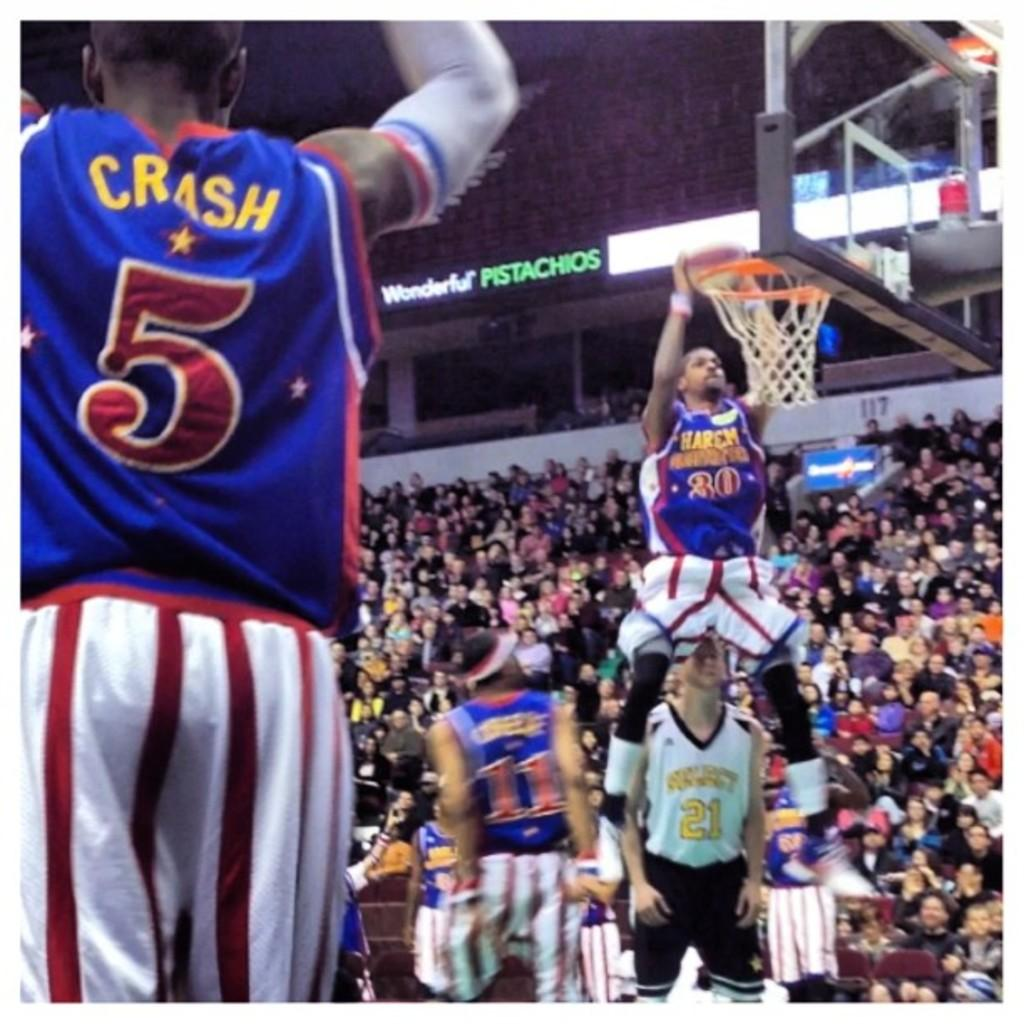<image>
Write a terse but informative summary of the picture. Several basketball players with blue or white jerseys - the blue jerseys read HARLEM GLOBETROTTERS 